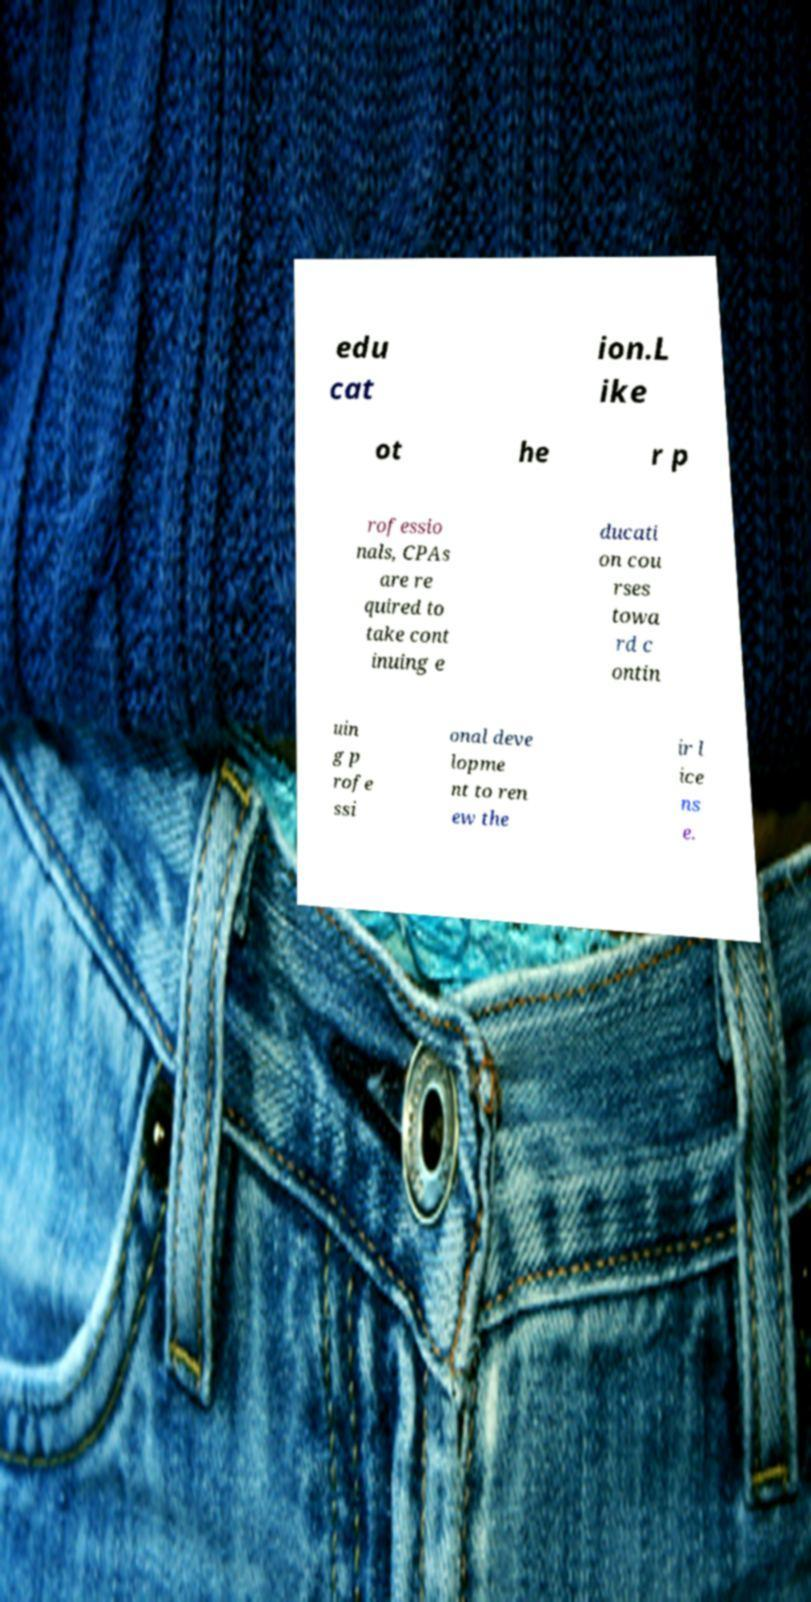Please read and relay the text visible in this image. What does it say? edu cat ion.L ike ot he r p rofessio nals, CPAs are re quired to take cont inuing e ducati on cou rses towa rd c ontin uin g p rofe ssi onal deve lopme nt to ren ew the ir l ice ns e. 